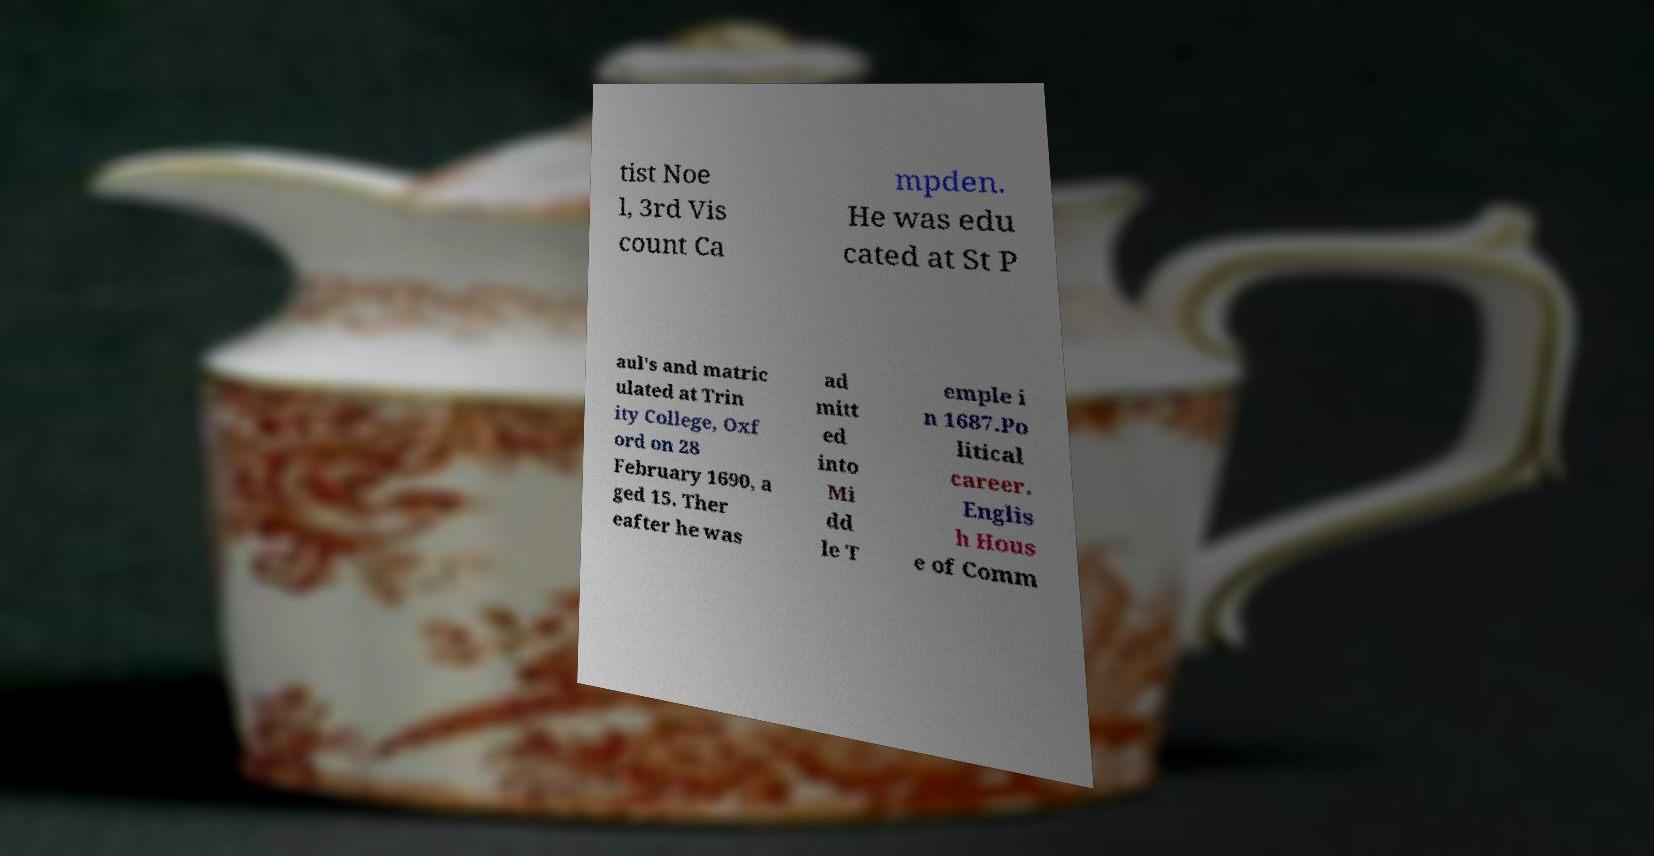I need the written content from this picture converted into text. Can you do that? tist Noe l, 3rd Vis count Ca mpden. He was edu cated at St P aul's and matric ulated at Trin ity College, Oxf ord on 28 February 1690, a ged 15. Ther eafter he was ad mitt ed into Mi dd le T emple i n 1687.Po litical career. Englis h Hous e of Comm 